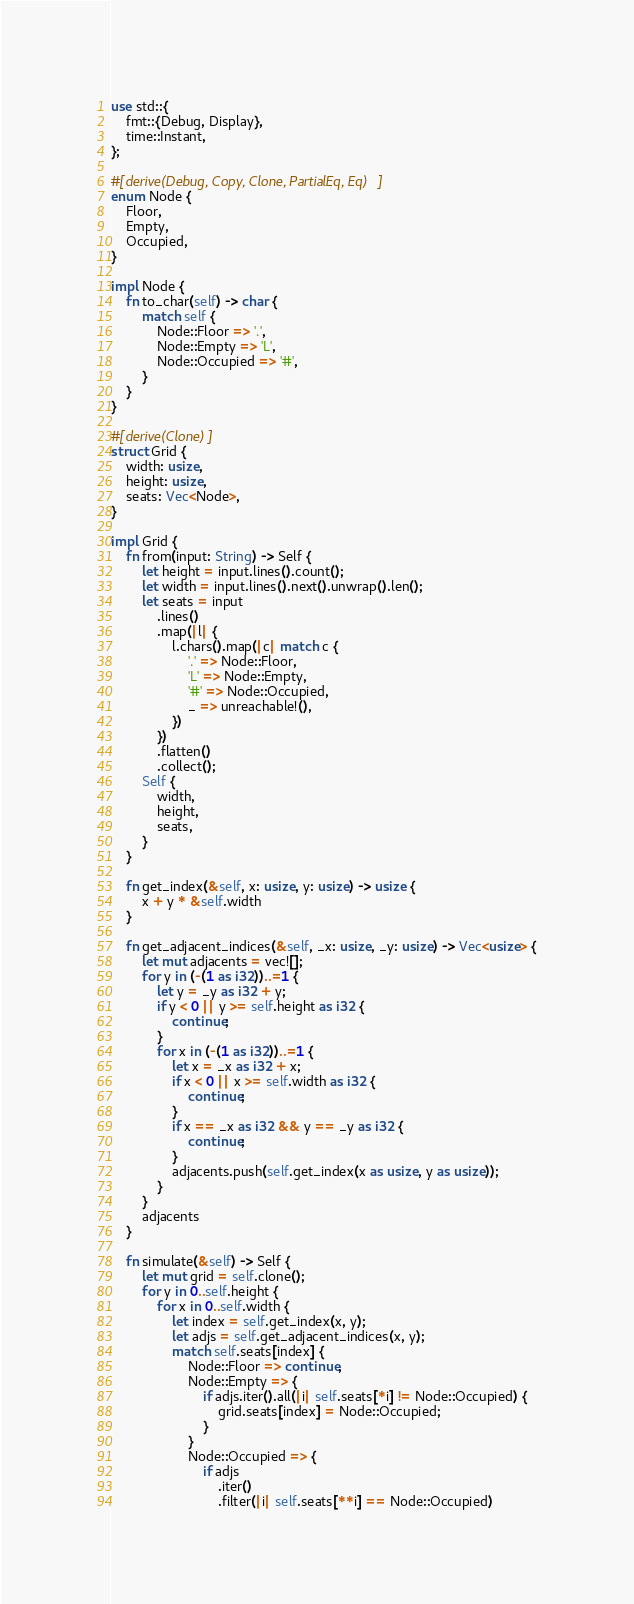Convert code to text. <code><loc_0><loc_0><loc_500><loc_500><_Rust_>use std::{
    fmt::{Debug, Display},
    time::Instant,
};

#[derive(Debug, Copy, Clone, PartialEq, Eq)]
enum Node {
    Floor,
    Empty,
    Occupied,
}

impl Node {
    fn to_char(self) -> char {
        match self {
            Node::Floor => '.',
            Node::Empty => 'L',
            Node::Occupied => '#',
        }
    }
}

#[derive(Clone)]
struct Grid {
    width: usize,
    height: usize,
    seats: Vec<Node>,
}

impl Grid {
    fn from(input: String) -> Self {
        let height = input.lines().count();
        let width = input.lines().next().unwrap().len();
        let seats = input
            .lines()
            .map(|l| {
                l.chars().map(|c| match c {
                    '.' => Node::Floor,
                    'L' => Node::Empty,
                    '#' => Node::Occupied,
                    _ => unreachable!(),
                })
            })
            .flatten()
            .collect();
        Self {
            width,
            height,
            seats,
        }
    }

    fn get_index(&self, x: usize, y: usize) -> usize {
        x + y * &self.width
    }

    fn get_adjacent_indices(&self, _x: usize, _y: usize) -> Vec<usize> {
        let mut adjacents = vec![];
        for y in (-(1 as i32))..=1 {
            let y = _y as i32 + y;
            if y < 0 || y >= self.height as i32 {
                continue;
            }
            for x in (-(1 as i32))..=1 {
                let x = _x as i32 + x;
                if x < 0 || x >= self.width as i32 {
                    continue;
                }
                if x == _x as i32 && y == _y as i32 {
                    continue;
                }
                adjacents.push(self.get_index(x as usize, y as usize));
            }
        }
        adjacents
    }

    fn simulate(&self) -> Self {
        let mut grid = self.clone();
        for y in 0..self.height {
            for x in 0..self.width {
                let index = self.get_index(x, y);
                let adjs = self.get_adjacent_indices(x, y);
                match self.seats[index] {
                    Node::Floor => continue,
                    Node::Empty => {
                        if adjs.iter().all(|i| self.seats[*i] != Node::Occupied) {
                            grid.seats[index] = Node::Occupied;
                        }
                    }
                    Node::Occupied => {
                        if adjs
                            .iter()
                            .filter(|i| self.seats[**i] == Node::Occupied)</code> 